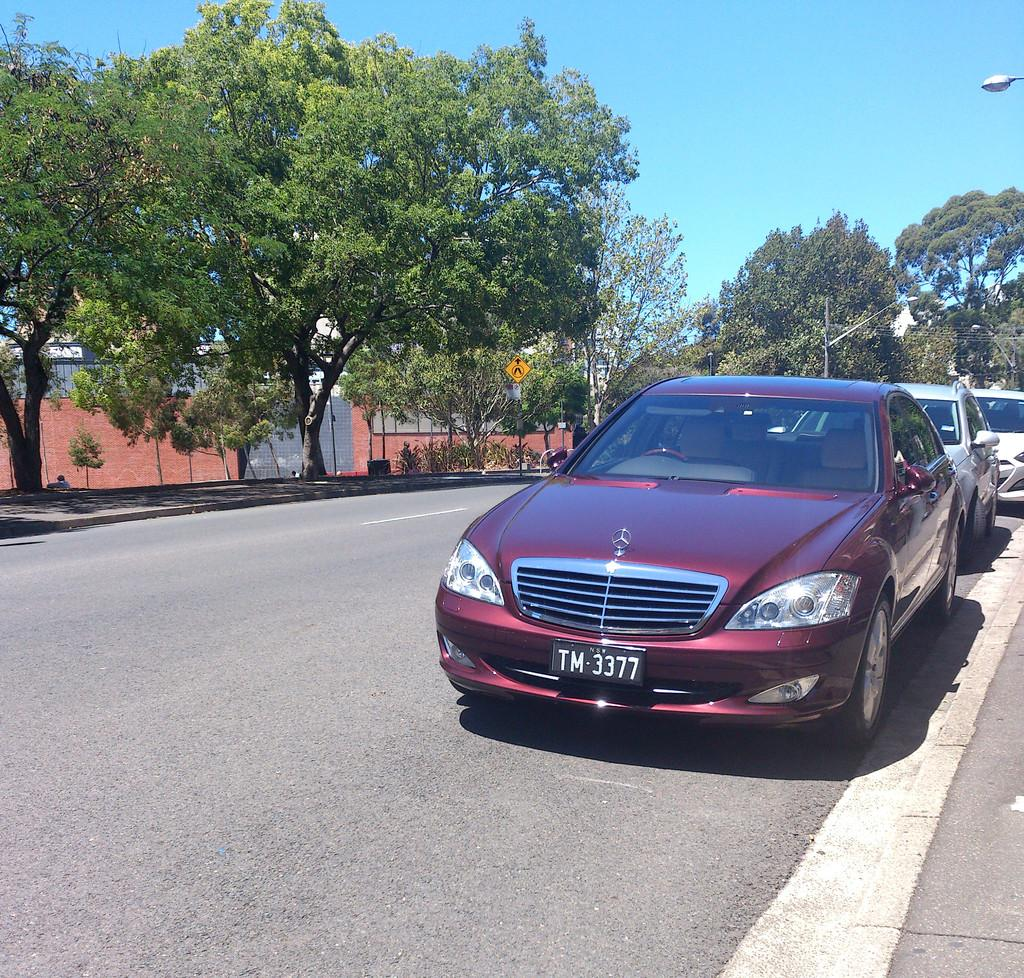What is located in the center of the image? There are vehicles on the road in the center of the image. What can be seen in the background of the image? There are trees and poles in the background of the image. What is visible at the top of the image? The sky is visible at the top of the image. What is the purpose of the arm in the image? There is no arm present in the image. 